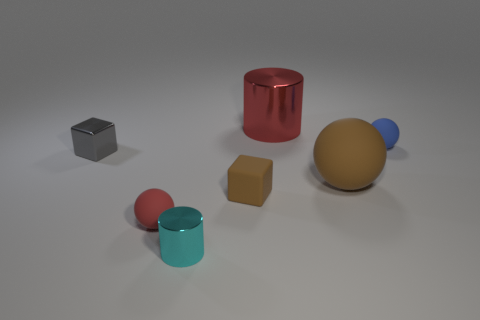Subtract all red spheres. How many spheres are left? 2 Subtract all red balls. How many balls are left? 2 Add 2 tiny gray metallic objects. How many objects exist? 9 Subtract all cylinders. How many objects are left? 5 Subtract 1 blocks. How many blocks are left? 1 Subtract all cyan cylinders. Subtract all cyan blocks. How many cylinders are left? 1 Subtract all cyan cylinders. How many brown balls are left? 1 Subtract all small cyan metallic cylinders. Subtract all tiny brown objects. How many objects are left? 5 Add 7 big matte spheres. How many big matte spheres are left? 8 Add 6 small brown matte things. How many small brown matte things exist? 7 